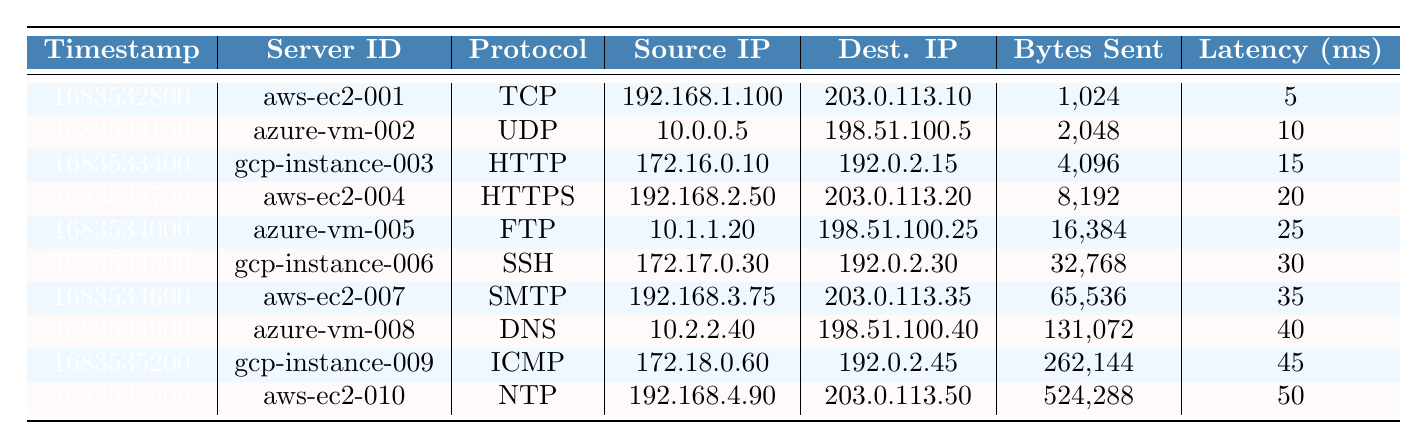What is the server ID of the entry with the maximum bytes sent? From the table, we can see that the maximum value in the "Bytes Sent" column is 524,288, which corresponds to the last row. The server ID for that row is "aws-ec2-010".
Answer: aws-ec2-010 What protocol is used by the server with ID 'gcp-instance-006'? Looking at the row corresponding to 'gcp-instance-006', we see that the protocol column shows 'SSH'.
Answer: SSH Which entry has the highest latency, and what is its value? The highest value in the "Latency (ms)" column is 50, which corresponds to the last entry in the table.
Answer: 50 ms (aws-ec2-010) What is the total number of bytes sent across all entries? To calculate the total, sum all values in the "Bytes Sent" column: 1,024 + 2,048 + 4,096 + 8,192 + 16,384 + 32,768 + 65,536 + 131,072 + 262,144 + 524,288 = 1,049,088.
Answer: 1,049,088 bytes What is the average latency of all entries? To find the average latency, first, sum the values: 5 + 10 + 15 + 20 + 25 + 30 + 35 + 40 + 45 + 50 =  275, then divide by the number of entries (10), resulting in an average latency of 27.5 ms.
Answer: 27.5 ms Is there an entry with a status code of 404? Checking the "Status Code" column, I see the value 404 listed in the table. Therefore, yes, there is an entry with that status code.
Answer: Yes Which entry had the lowest bytes received? The lowest value in the "Bytes Received" column is 512, which appears in the first entry's row (aws-ec2-001).
Answer: 512 bytes (aws-ec2-001) What is the difference in bytes sent between the entries with the highest and lowest values? The maximum bytes sent is 524,288 (aws-ec2-010) and the minimum is 1,024 (aws-ec2-001). The difference is 524,288 - 1,024 = 523,264 bytes.
Answer: 523,264 bytes Which entry has the same source and destination IPs, if any? Reviewing the "Source IP" and "Dest. IP" columns, I see no entries with the same IPs, hence there is none.
Answer: None How many distinct protocols are listed in the table? The unique protocols listed are TCP, UDP, HTTP, HTTPS, FTP, SSH, SMTP, DNS, ICMP, and NTP, totaling 10 distinct protocols.
Answer: 10 What is the maximum response time recorded in the dataset? The maximum value in the "Response Time (ms)" column is 275, found in the last entry.
Answer: 275 ms 